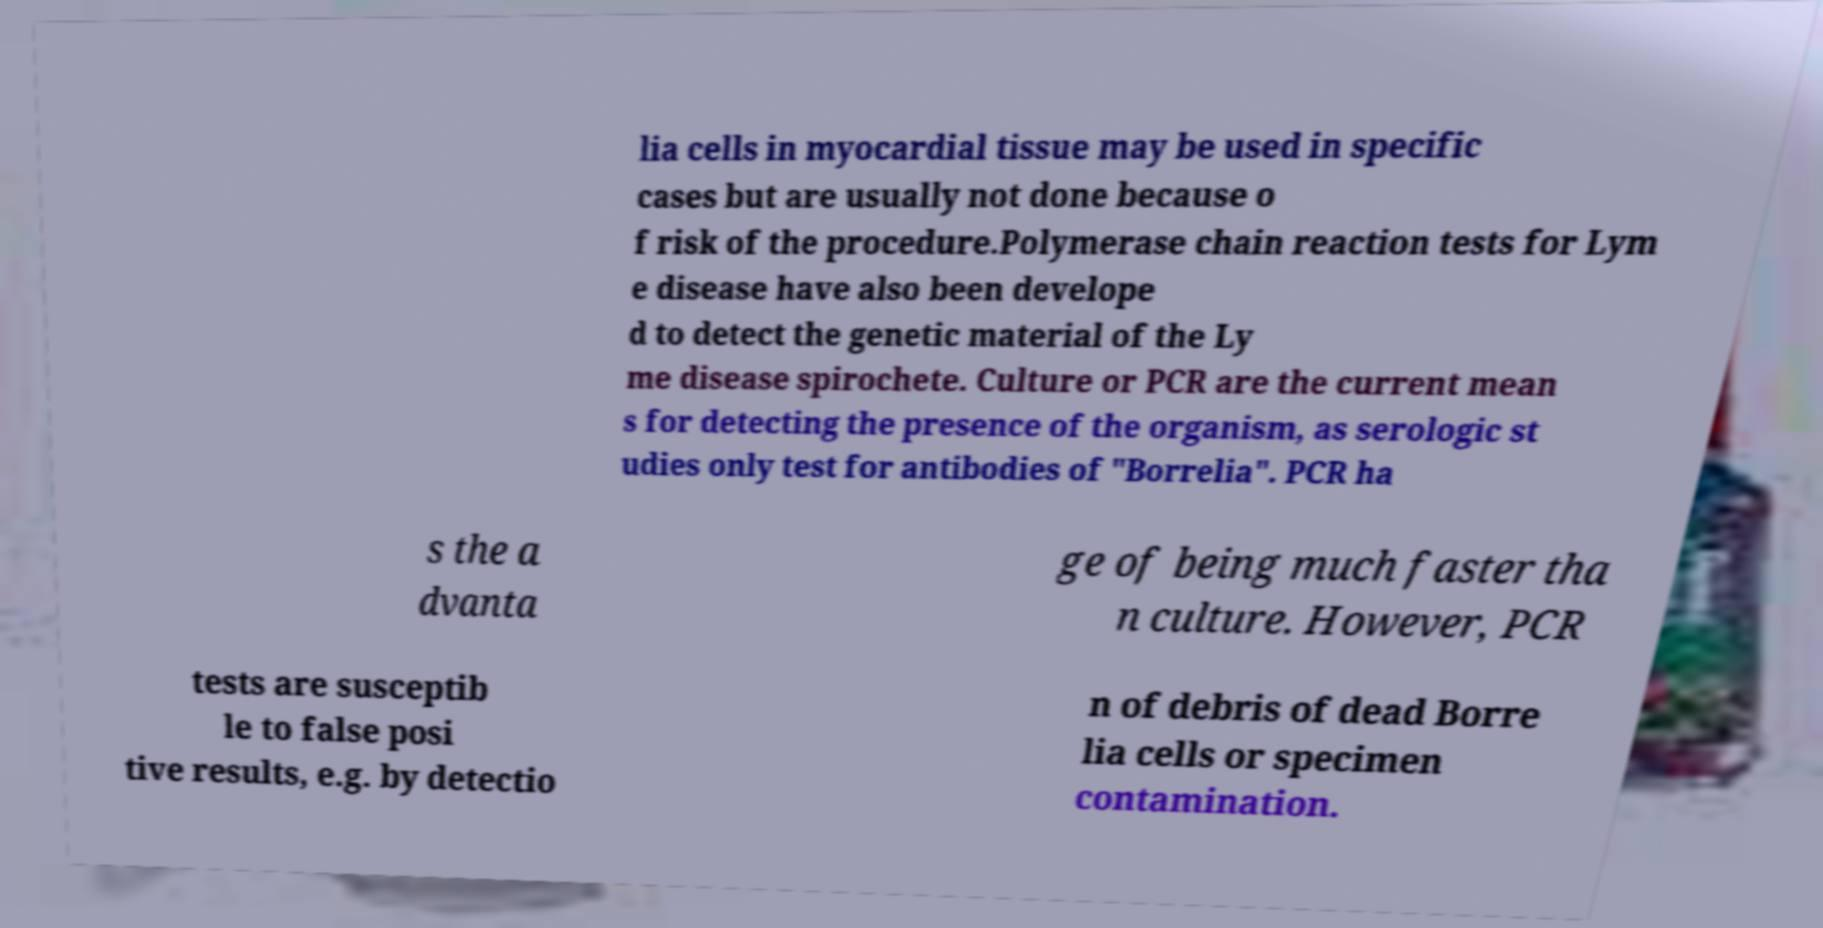For documentation purposes, I need the text within this image transcribed. Could you provide that? lia cells in myocardial tissue may be used in specific cases but are usually not done because o f risk of the procedure.Polymerase chain reaction tests for Lym e disease have also been develope d to detect the genetic material of the Ly me disease spirochete. Culture or PCR are the current mean s for detecting the presence of the organism, as serologic st udies only test for antibodies of "Borrelia". PCR ha s the a dvanta ge of being much faster tha n culture. However, PCR tests are susceptib le to false posi tive results, e.g. by detectio n of debris of dead Borre lia cells or specimen contamination. 